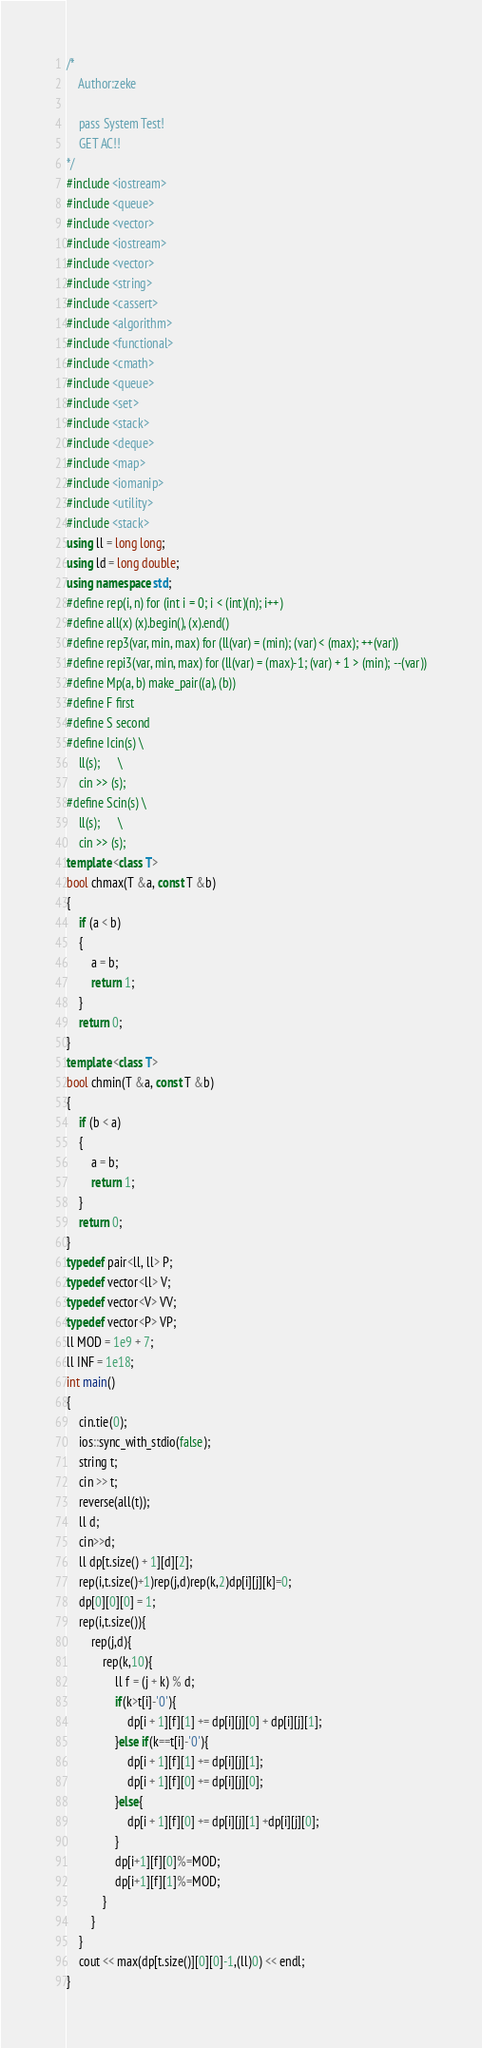Convert code to text. <code><loc_0><loc_0><loc_500><loc_500><_C++_>/*
    Author:zeke
    
    pass System Test!
    GET AC!!
*/
#include <iostream>
#include <queue>
#include <vector>
#include <iostream>
#include <vector>
#include <string>
#include <cassert>
#include <algorithm>
#include <functional>
#include <cmath>
#include <queue>
#include <set>
#include <stack>
#include <deque>
#include <map>
#include <iomanip>
#include <utility>
#include <stack>
using ll = long long;
using ld = long double;
using namespace std;
#define rep(i, n) for (int i = 0; i < (int)(n); i++)
#define all(x) (x).begin(), (x).end()
#define rep3(var, min, max) for (ll(var) = (min); (var) < (max); ++(var))
#define repi3(var, min, max) for (ll(var) = (max)-1; (var) + 1 > (min); --(var))
#define Mp(a, b) make_pair((a), (b))
#define F first
#define S second
#define Icin(s) \
    ll(s);      \
    cin >> (s);
#define Scin(s) \
    ll(s);      \
    cin >> (s);
template <class T>
bool chmax(T &a, const T &b)
{
    if (a < b)
    {
        a = b;
        return 1;
    }
    return 0;
}
template <class T>
bool chmin(T &a, const T &b)
{
    if (b < a)
    {
        a = b;
        return 1;
    }
    return 0;
}
typedef pair<ll, ll> P;
typedef vector<ll> V;
typedef vector<V> VV;
typedef vector<P> VP;
ll MOD = 1e9 + 7;
ll INF = 1e18;
int main()
{
    cin.tie(0);
    ios::sync_with_stdio(false);
    string t;
    cin >> t;
    reverse(all(t));
    ll d;
    cin>>d;
    ll dp[t.size() + 1][d][2];
    rep(i,t.size()+1)rep(j,d)rep(k,2)dp[i][j][k]=0;
    dp[0][0][0] = 1;
    rep(i,t.size()){
        rep(j,d){
            rep(k,10){
                ll f = (j + k) % d;
                if(k>t[i]-'0'){
                    dp[i + 1][f][1] += dp[i][j][0] + dp[i][j][1];
                }else if(k==t[i]-'0'){
                    dp[i + 1][f][1] += dp[i][j][1];
                    dp[i + 1][f][0] += dp[i][j][0];
                }else{
                    dp[i + 1][f][0] += dp[i][j][1] +dp[i][j][0];
                }
                dp[i+1][f][0]%=MOD;
                dp[i+1][f][1]%=MOD;
            }
        }
    }
    cout << max(dp[t.size()][0][0]-1,(ll)0) << endl;
}</code> 